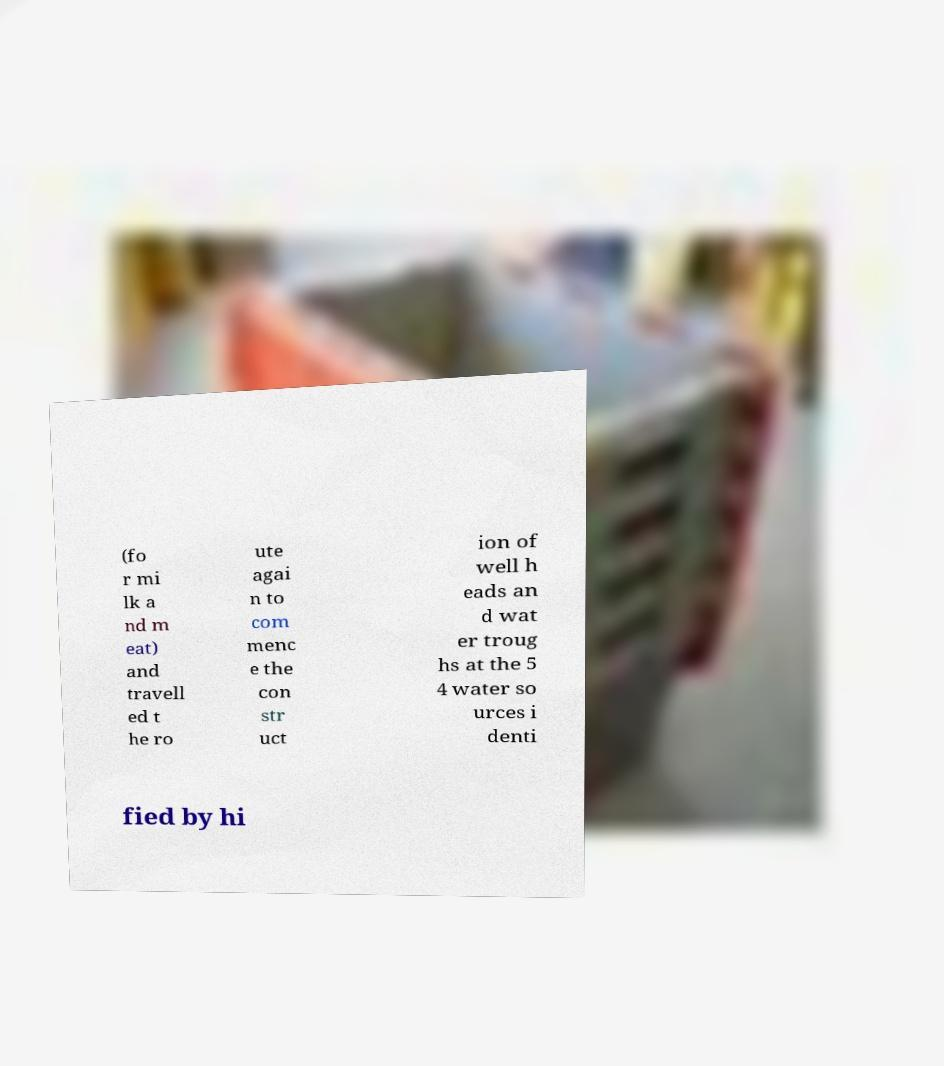Could you assist in decoding the text presented in this image and type it out clearly? (fo r mi lk a nd m eat) and travell ed t he ro ute agai n to com menc e the con str uct ion of well h eads an d wat er troug hs at the 5 4 water so urces i denti fied by hi 